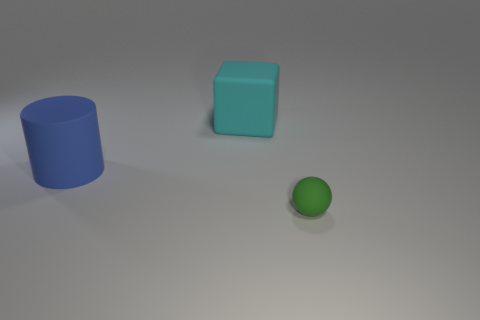There is a cyan thing that is on the right side of the blue matte cylinder; is its shape the same as the green object?
Offer a very short reply. No. What is the large cyan block made of?
Your answer should be very brief. Rubber. What is the shape of the cyan thing that is the same size as the blue matte thing?
Give a very brief answer. Cube. The matte object that is left of the big matte object that is on the right side of the big rubber cylinder is what color?
Ensure brevity in your answer.  Blue. Is there a cyan rubber cube right of the thing that is behind the big matte object that is in front of the big cyan block?
Your answer should be compact. No. What is the color of the large cylinder that is the same material as the big cyan object?
Offer a very short reply. Blue. How many green things are made of the same material as the large blue thing?
Your answer should be compact. 1. How many things are things to the left of the big cyan block or large blue rubber things?
Keep it short and to the point. 1. What size is the rubber object right of the large rubber object that is right of the rubber thing to the left of the large cyan block?
Provide a succinct answer. Small. Is there any other thing that is the same shape as the blue rubber thing?
Ensure brevity in your answer.  No. 